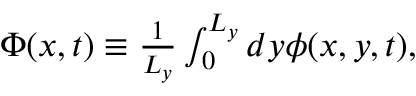Convert formula to latex. <formula><loc_0><loc_0><loc_500><loc_500>\begin{array} { r } { \Phi ( x , t ) \equiv \frac { 1 } { L _ { y } } \int _ { 0 } ^ { L _ { y } } d y \phi ( x , y , t ) , } \end{array}</formula> 